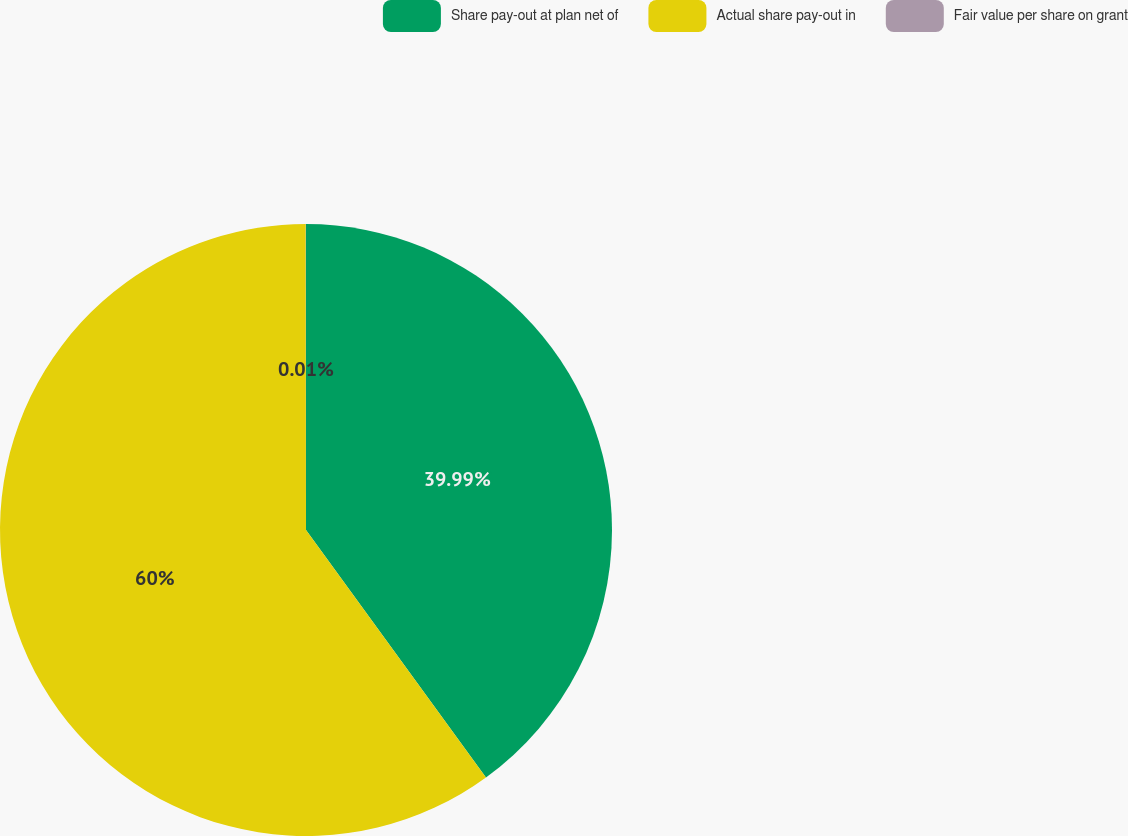<chart> <loc_0><loc_0><loc_500><loc_500><pie_chart><fcel>Share pay-out at plan net of<fcel>Actual share pay-out in<fcel>Fair value per share on grant<nl><fcel>39.99%<fcel>59.99%<fcel>0.01%<nl></chart> 